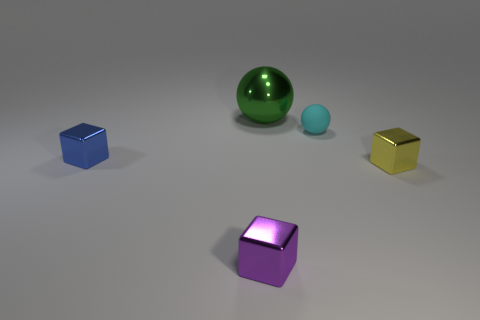Are there any other things that are the same size as the green metallic ball?
Give a very brief answer. No. What is the size of the metal ball?
Your response must be concise. Large. What size is the metal object behind the small blue cube that is in front of the sphere that is in front of the large green object?
Make the answer very short. Large. There is a purple object that is the same size as the yellow shiny object; what is its shape?
Your answer should be very brief. Cube. Is the number of small shiny blocks less than the number of blue balls?
Make the answer very short. No. What number of cyan matte spheres are the same size as the blue metal object?
Give a very brief answer. 1. What material is the big green sphere?
Offer a very short reply. Metal. There is a metal thing in front of the small yellow object; what size is it?
Make the answer very short. Small. How many big green metallic things are the same shape as the blue thing?
Offer a terse response. 0. What is the shape of the small yellow thing that is the same material as the tiny blue cube?
Your response must be concise. Cube. 